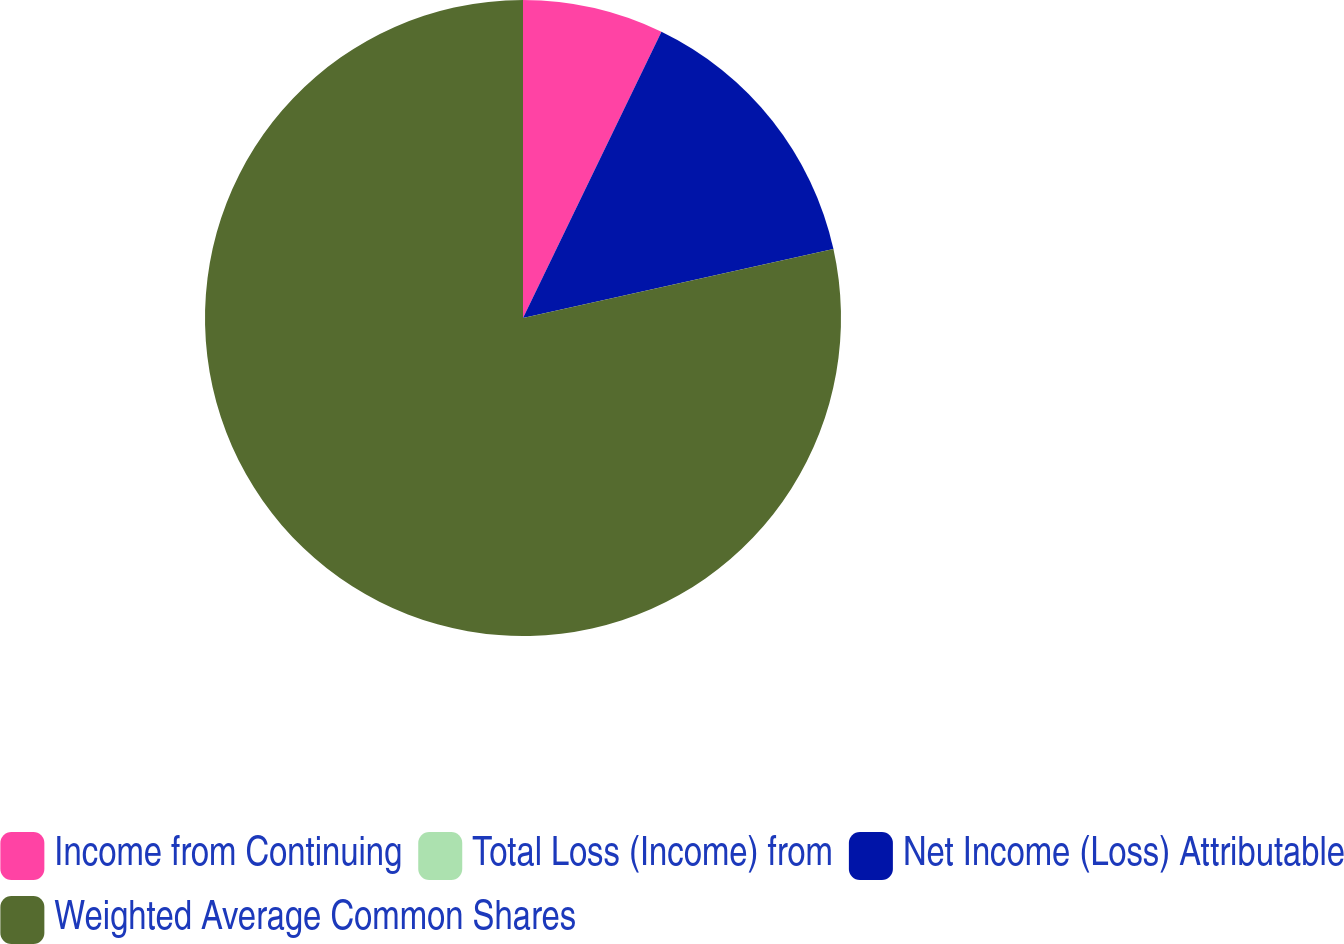Convert chart to OTSL. <chart><loc_0><loc_0><loc_500><loc_500><pie_chart><fcel>Income from Continuing<fcel>Total Loss (Income) from<fcel>Net Income (Loss) Attributable<fcel>Weighted Average Common Shares<nl><fcel>7.17%<fcel>0.0%<fcel>14.35%<fcel>78.48%<nl></chart> 